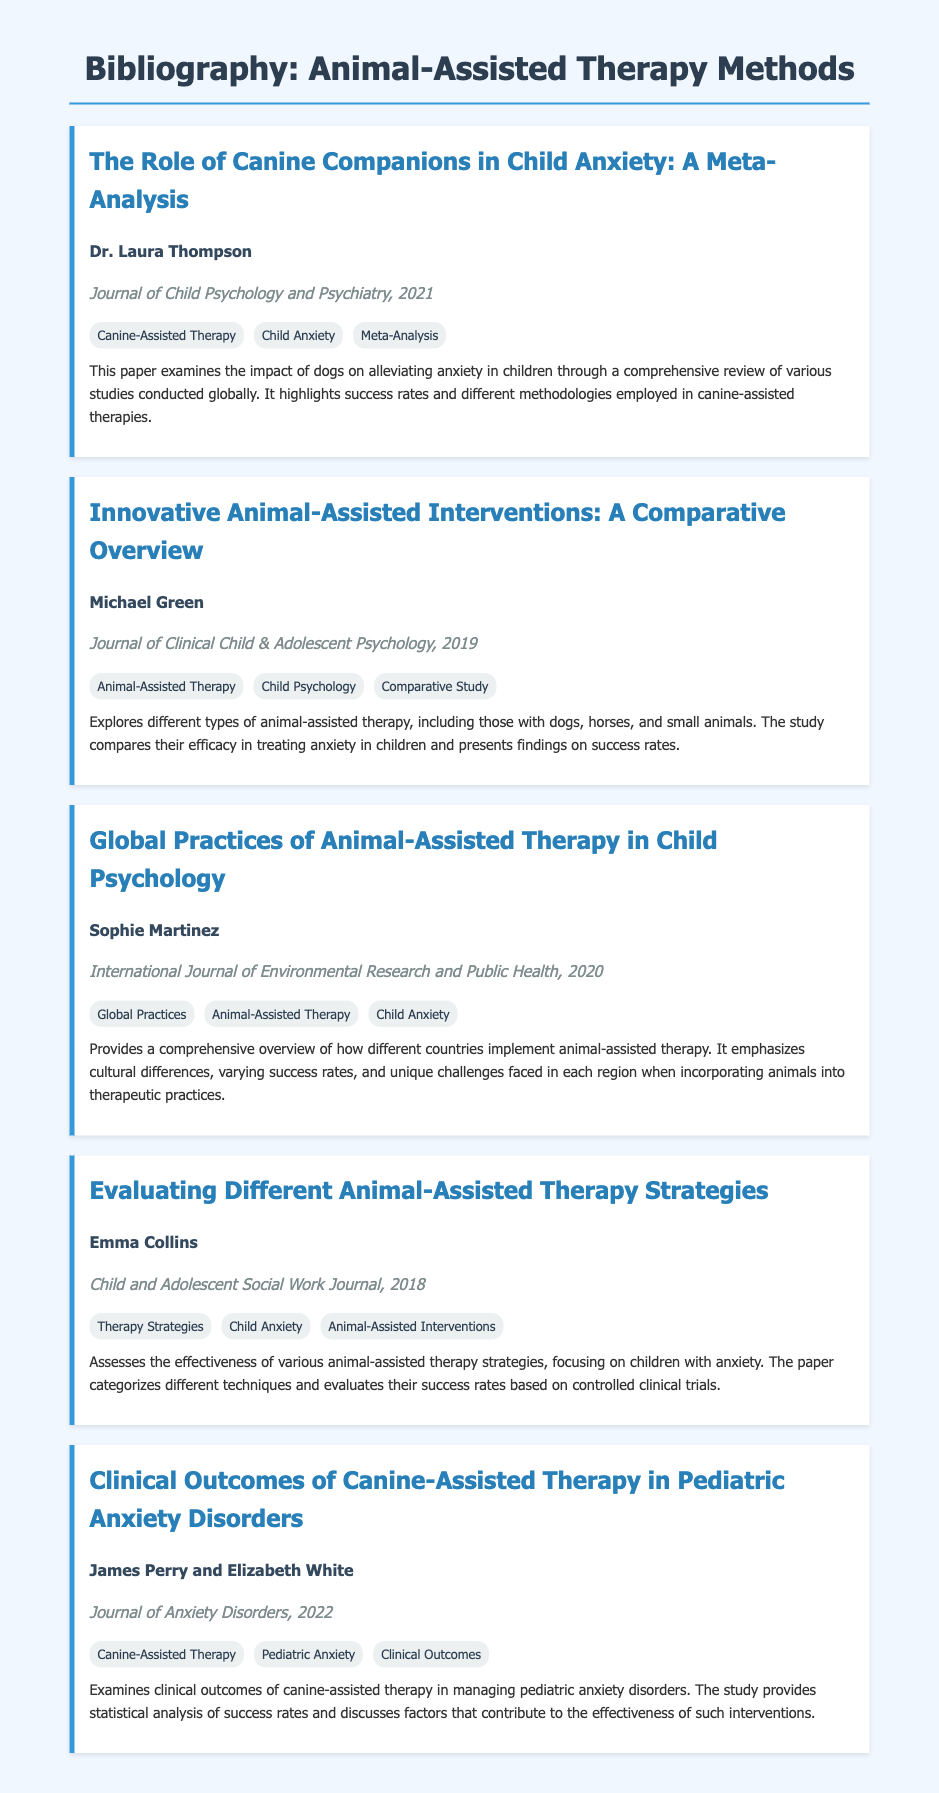What is the title of the first paper listed? The first paper listed is "The Role of Canine Companions in Child Anxiety: A Meta-Analysis".
Answer: The Role of Canine Companions in Child Anxiety: A Meta-Analysis Who authored the paper on clinical outcomes in pediatric anxiety disorders? The clinical outcomes paper was authored by James Perry and Elizabeth White.
Answer: James Perry and Elizabeth White In which journal was "Evaluating Different Animal-Assisted Therapy Strategies" published? The paper was published in the Child and Adolescent Social Work Journal.
Answer: Child and Adolescent Social Work Journal What year was "Innovative Animal-Assisted Interventions: A Comparative Overview" published? This paper was published in 2019.
Answer: 2019 Which paper focuses on global practices of animal-assisted therapy? The paper titled "Global Practices of Animal-Assisted Therapy in Child Psychology" focuses on that subject.
Answer: Global Practices of Animal-Assisted Therapy in Child Psychology How many keywords are associated with the paper by Michael Green? The paper by Michael Green has three keywords associated with it.
Answer: three What is the main focus of the summary in the paper by Emma Collins? The main focus is the effectiveness of various animal-assisted therapy strategies for children with anxiety.
Answer: Effectiveness of various animal-assisted therapy strategies What type of study is primarily mentioned in Dr. Laura Thompson's paper? Dr. Laura Thompson’s paper primarily discusses a meta-analysis.
Answer: meta-analysis How does Sophie Martinez's paper contribute to understanding different countries? It provides a comprehensive overview of how different countries implement animal-assisted therapy.
Answer: Overview of implementation in different countries 